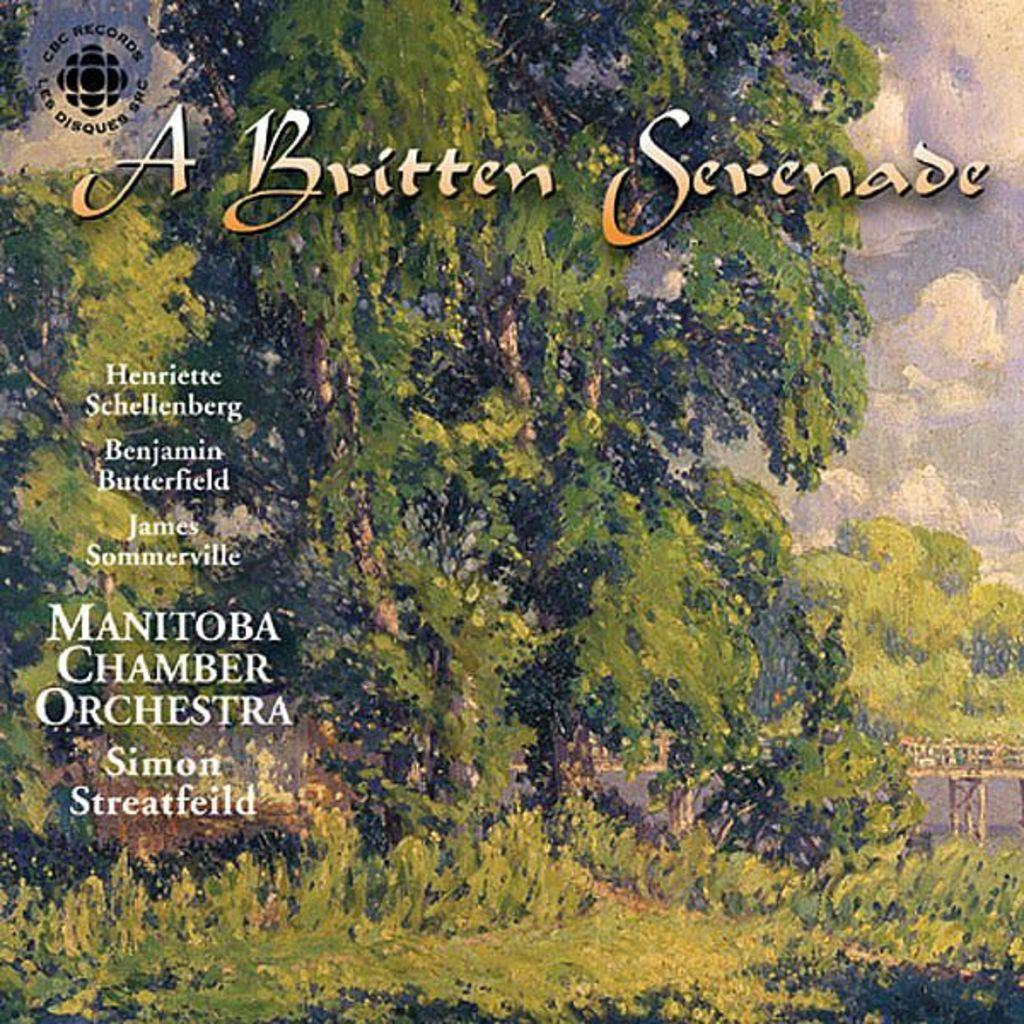What is featured on the poster in the image? There is a poster in the image, which contains images of trees. What else can be seen on the poster besides the images of trees? There is some text on the poster. What type of sky is depicted on the poster? The poster depicts a sky with clouds. What type of experience can be gained from the argument on the poster? There is no argument present on the poster; it features images of trees, text, and a sky with clouds. 